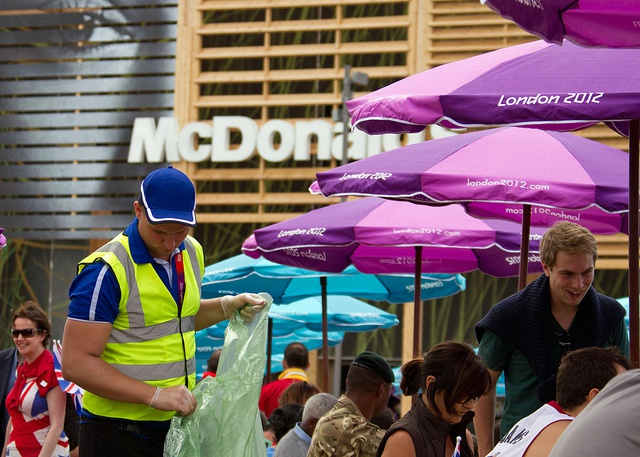Describe the objects in this image and their specific colors. I can see people in black, navy, brown, and olive tones, umbrella in black, violet, purple, pink, and magenta tones, umbrella in black, violet, and purple tones, people in black, maroon, brown, and gray tones, and umbrella in black, violet, and purple tones in this image. 